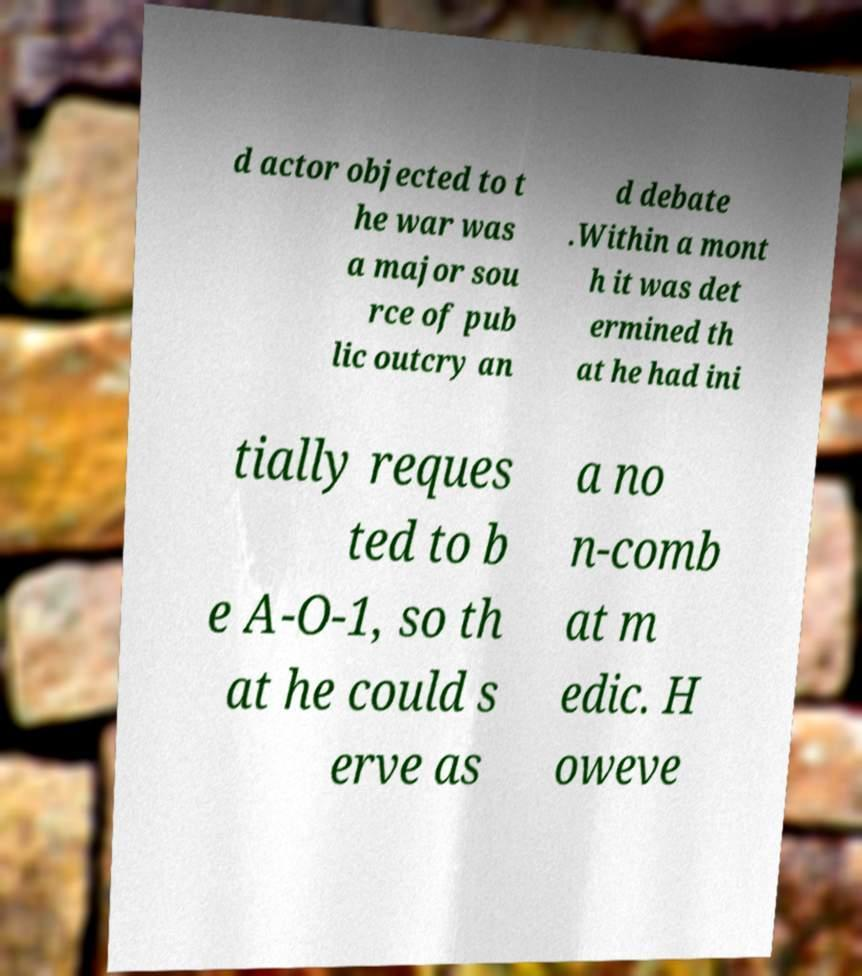What messages or text are displayed in this image? I need them in a readable, typed format. d actor objected to t he war was a major sou rce of pub lic outcry an d debate .Within a mont h it was det ermined th at he had ini tially reques ted to b e A-O-1, so th at he could s erve as a no n-comb at m edic. H oweve 